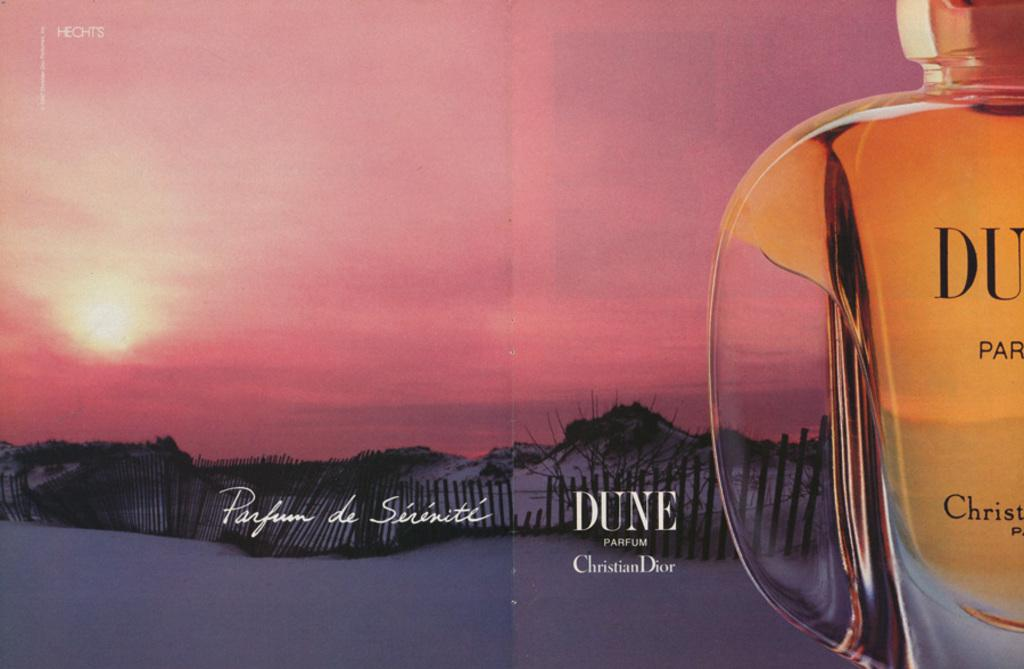<image>
Offer a succinct explanation of the picture presented. An ad for Dune perfume says that it was made by Christian Dior. 